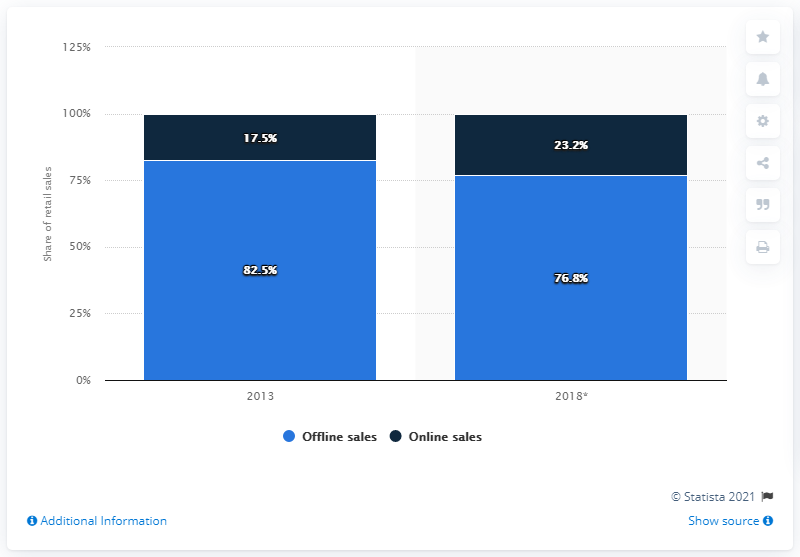What trends can we see in the German electricals and electronics market from the data? The image illustrates a clear trend in the German electricals and electronics market towards increasing online sales. Between 2013 and an unspecified later year, there's a visible rise in online sales share from 17.5% to 23.2%. 